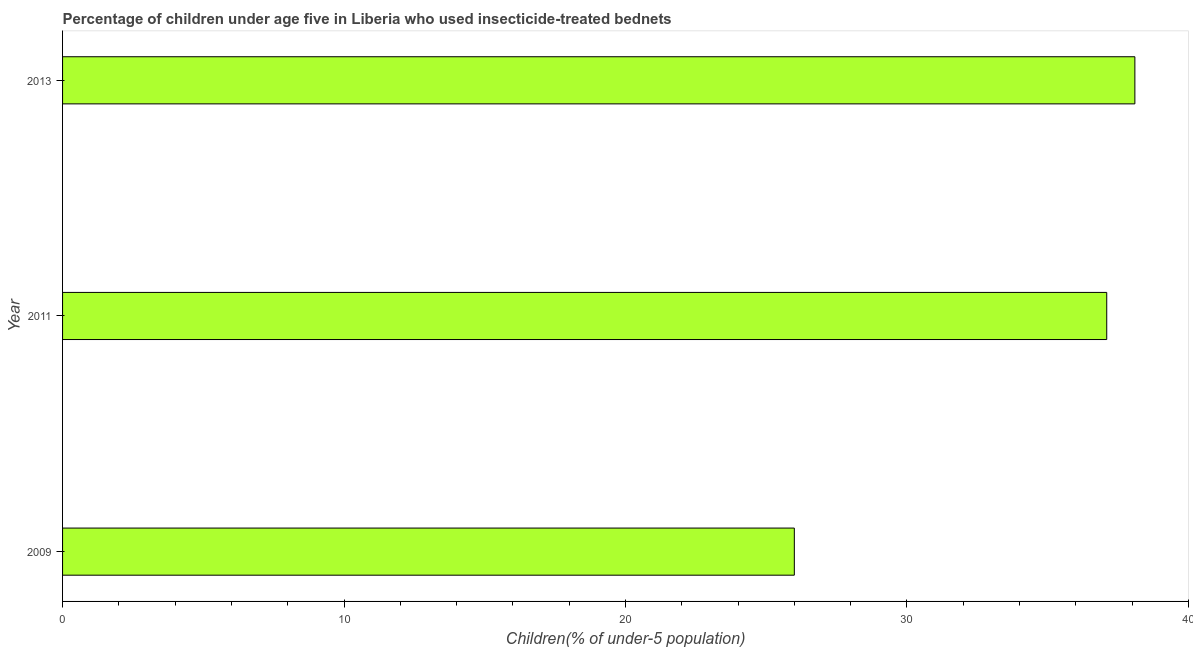Does the graph contain any zero values?
Make the answer very short. No. What is the title of the graph?
Provide a succinct answer. Percentage of children under age five in Liberia who used insecticide-treated bednets. What is the label or title of the X-axis?
Give a very brief answer. Children(% of under-5 population). What is the percentage of children who use of insecticide-treated bed nets in 2011?
Your answer should be compact. 37.1. Across all years, what is the maximum percentage of children who use of insecticide-treated bed nets?
Ensure brevity in your answer.  38.1. In which year was the percentage of children who use of insecticide-treated bed nets maximum?
Your answer should be very brief. 2013. In which year was the percentage of children who use of insecticide-treated bed nets minimum?
Offer a terse response. 2009. What is the sum of the percentage of children who use of insecticide-treated bed nets?
Make the answer very short. 101.2. What is the difference between the percentage of children who use of insecticide-treated bed nets in 2009 and 2011?
Your answer should be very brief. -11.1. What is the average percentage of children who use of insecticide-treated bed nets per year?
Make the answer very short. 33.73. What is the median percentage of children who use of insecticide-treated bed nets?
Ensure brevity in your answer.  37.1. What is the ratio of the percentage of children who use of insecticide-treated bed nets in 2009 to that in 2011?
Keep it short and to the point. 0.7. Is the percentage of children who use of insecticide-treated bed nets in 2009 less than that in 2013?
Your response must be concise. Yes. What is the difference between the highest and the second highest percentage of children who use of insecticide-treated bed nets?
Your answer should be compact. 1. In how many years, is the percentage of children who use of insecticide-treated bed nets greater than the average percentage of children who use of insecticide-treated bed nets taken over all years?
Ensure brevity in your answer.  2. Are all the bars in the graph horizontal?
Your answer should be very brief. Yes. What is the difference between two consecutive major ticks on the X-axis?
Ensure brevity in your answer.  10. Are the values on the major ticks of X-axis written in scientific E-notation?
Offer a very short reply. No. What is the Children(% of under-5 population) of 2009?
Ensure brevity in your answer.  26. What is the Children(% of under-5 population) in 2011?
Make the answer very short. 37.1. What is the Children(% of under-5 population) of 2013?
Keep it short and to the point. 38.1. What is the difference between the Children(% of under-5 population) in 2009 and 2011?
Provide a short and direct response. -11.1. What is the difference between the Children(% of under-5 population) in 2011 and 2013?
Provide a succinct answer. -1. What is the ratio of the Children(% of under-5 population) in 2009 to that in 2011?
Keep it short and to the point. 0.7. What is the ratio of the Children(% of under-5 population) in 2009 to that in 2013?
Keep it short and to the point. 0.68. 